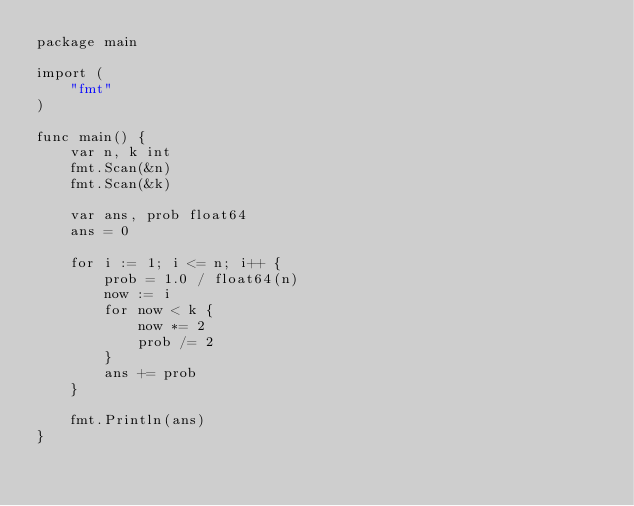<code> <loc_0><loc_0><loc_500><loc_500><_Go_>package main

import (
	"fmt"
)

func main() {
	var n, k int
	fmt.Scan(&n)
	fmt.Scan(&k)

	var ans, prob float64
	ans = 0

	for i := 1; i <= n; i++ {
		prob = 1.0 / float64(n)
		now := i
		for now < k {
			now *= 2
			prob /= 2
		}
		ans += prob
	}

	fmt.Println(ans)
}
</code> 